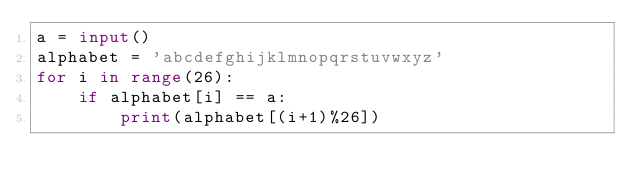Convert code to text. <code><loc_0><loc_0><loc_500><loc_500><_Python_>a = input()
alphabet = 'abcdefghijklmnopqrstuvwxyz'
for i in range(26):
	if alphabet[i] == a:
		print(alphabet[(i+1)%26])</code> 